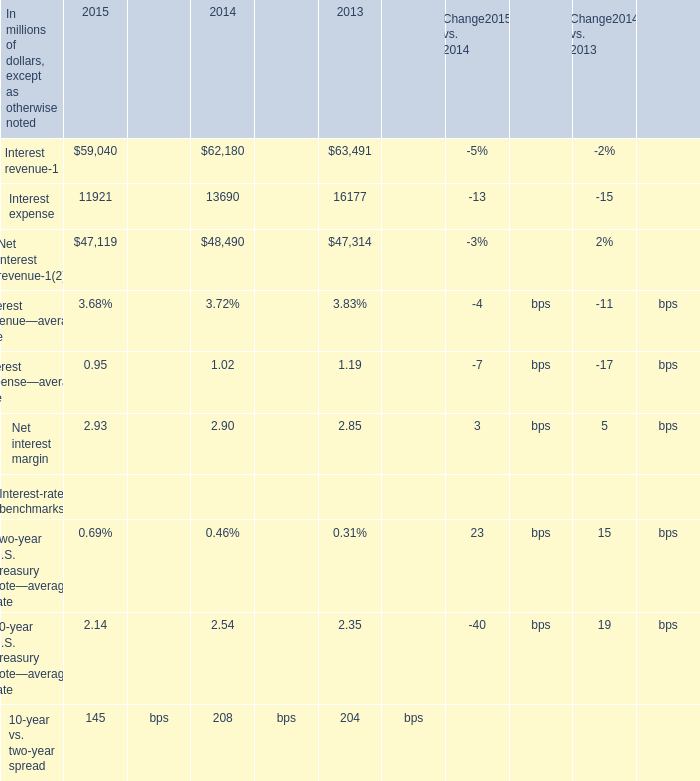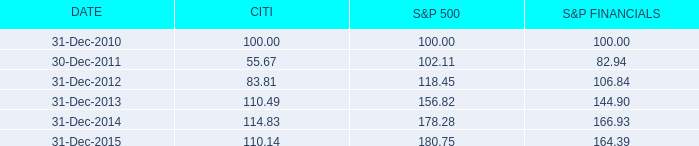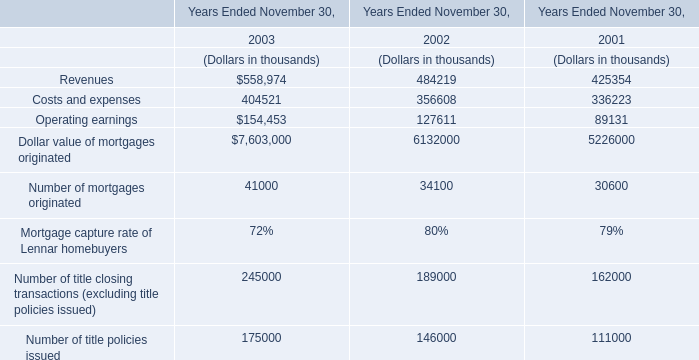what was the overall percentage growth of the cumulative total return for citi from 2010 to 2015 
Computations: ((110.14 - 100) / 100)
Answer: 0.1014. 